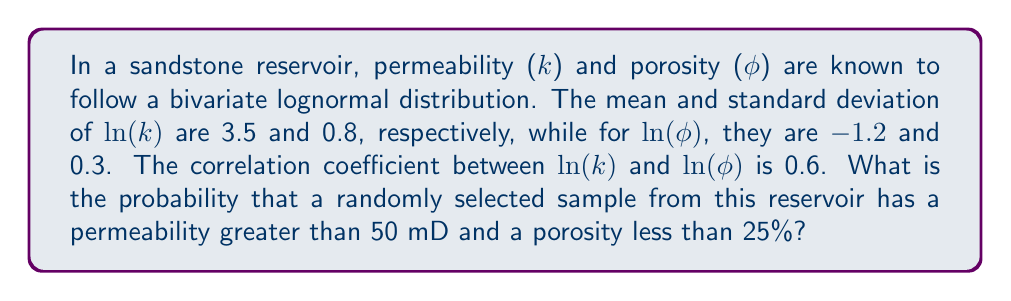Could you help me with this problem? To solve this problem, we'll follow these steps:

1) First, we need to standardize the given values:
   For permeability: $z_k = \frac{\ln(50) - 3.5}{0.8} = \frac{3.912 - 3.5}{0.8} = 0.515$
   For porosity: $z_φ = \frac{\ln(0.25) + 1.2}{0.3} = \frac{-1.386 + 1.2}{0.3} = -0.62$

2) The joint probability can be calculated using the bivariate normal distribution function:

   $$P(k > 50, φ < 0.25) = 1 - Φ(z_k) - Φ(z_φ) + Φ_2(z_k, z_φ, ρ)$$

   Where $Φ$ is the standard normal cumulative distribution function, $Φ_2$ is the bivariate normal cumulative distribution function, and $ρ$ is the correlation coefficient.

3) We can calculate $Φ(z_k)$ and $Φ(z_φ)$ using standard normal distribution tables or software:
   $Φ(0.515) ≈ 0.6967$
   $Φ(-0.62) ≈ 0.2676$

4) For $Φ_2(z_k, z_φ, ρ)$, we need to use numerical methods or specialized software. Using such methods, we get:
   $Φ_2(0.515, -0.62, 0.6) ≈ 0.1857$

5) Plugging these values into our equation:
   $P(k > 50, φ < 0.25) = 1 - 0.6967 - 0.2676 + 0.1857 = 0.2214$

Therefore, the probability is approximately 0.2214 or 22.14%.
Answer: 0.2214 